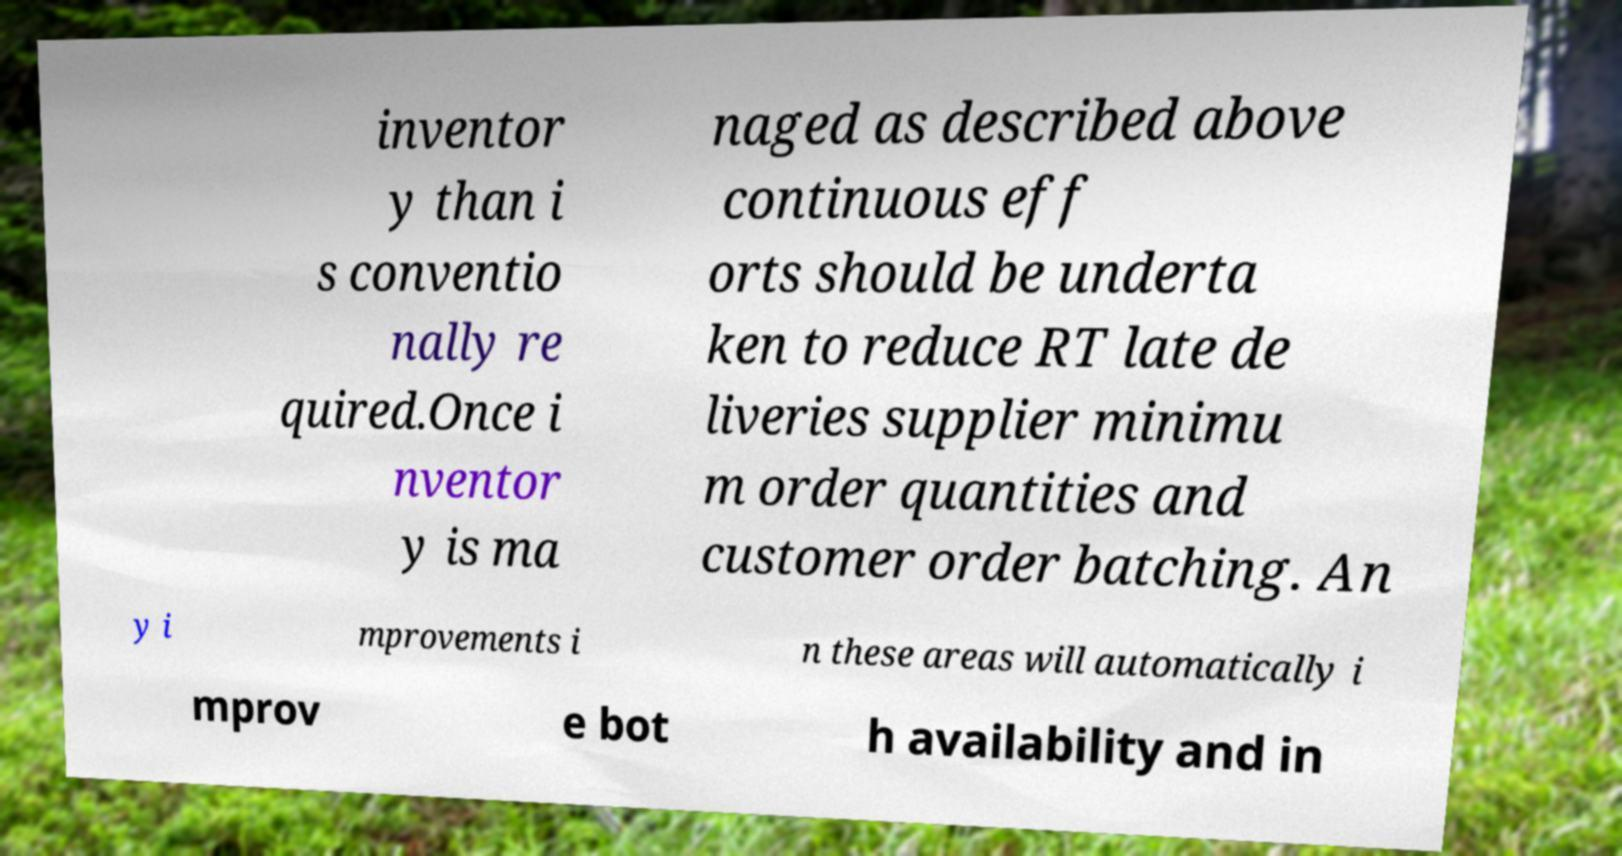Can you read and provide the text displayed in the image?This photo seems to have some interesting text. Can you extract and type it out for me? inventor y than i s conventio nally re quired.Once i nventor y is ma naged as described above continuous eff orts should be underta ken to reduce RT late de liveries supplier minimu m order quantities and customer order batching. An y i mprovements i n these areas will automatically i mprov e bot h availability and in 